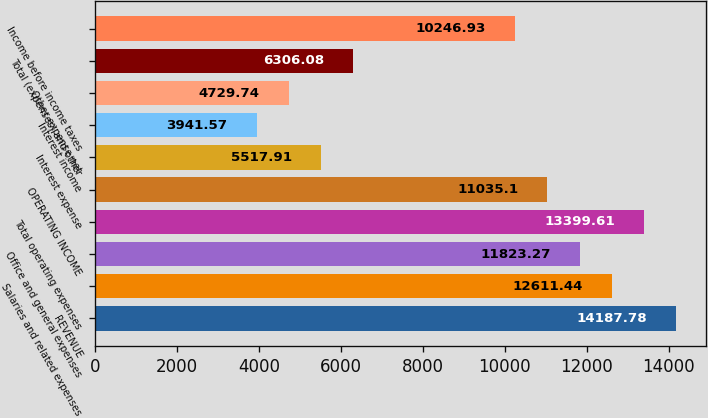Convert chart. <chart><loc_0><loc_0><loc_500><loc_500><bar_chart><fcel>REVENUE<fcel>Salaries and related expenses<fcel>Office and general expenses<fcel>Total operating expenses<fcel>OPERATING INCOME<fcel>Interest expense<fcel>Interest income<fcel>Other expense net<fcel>Total (expenses) and other<fcel>Income before income taxes<nl><fcel>14187.8<fcel>12611.4<fcel>11823.3<fcel>13399.6<fcel>11035.1<fcel>5517.91<fcel>3941.57<fcel>4729.74<fcel>6306.08<fcel>10246.9<nl></chart> 